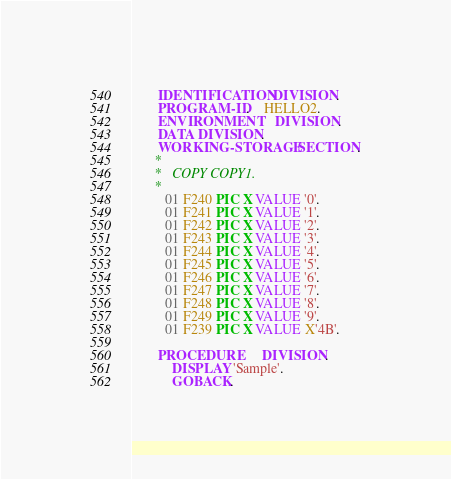<code> <loc_0><loc_0><loc_500><loc_500><_COBOL_>       IDENTIFICATION DIVISION.
       PROGRAM-ID.    HELLO2.
       ENVIRONMENT    DIVISION.
       DATA DIVISION.
       WORKING-STORAGE SECTION.
      *
      *   COPY COPY1.
      *
         01 F240 PIC X VALUE '0'.
         01 F241 PIC X VALUE '1'.
         01 F242 PIC X VALUE '2'.
         01 F243 PIC X VALUE '3'.
         01 F244 PIC X VALUE '4'.
         01 F245 PIC X VALUE '5'.
         01 F246 PIC X VALUE '6'.
         01 F247 PIC X VALUE '7'.
         01 F248 PIC X VALUE '8'.
         01 F249 PIC X VALUE '9'.
         01 F239 PIC X VALUE X'4B'.

       PROCEDURE      DIVISION.
           DISPLAY 'Sample'.
           GOBACK.</code> 